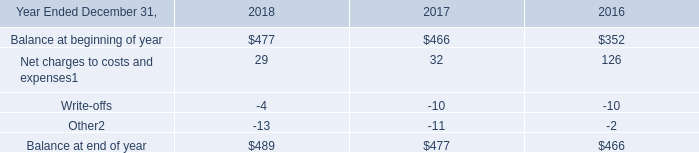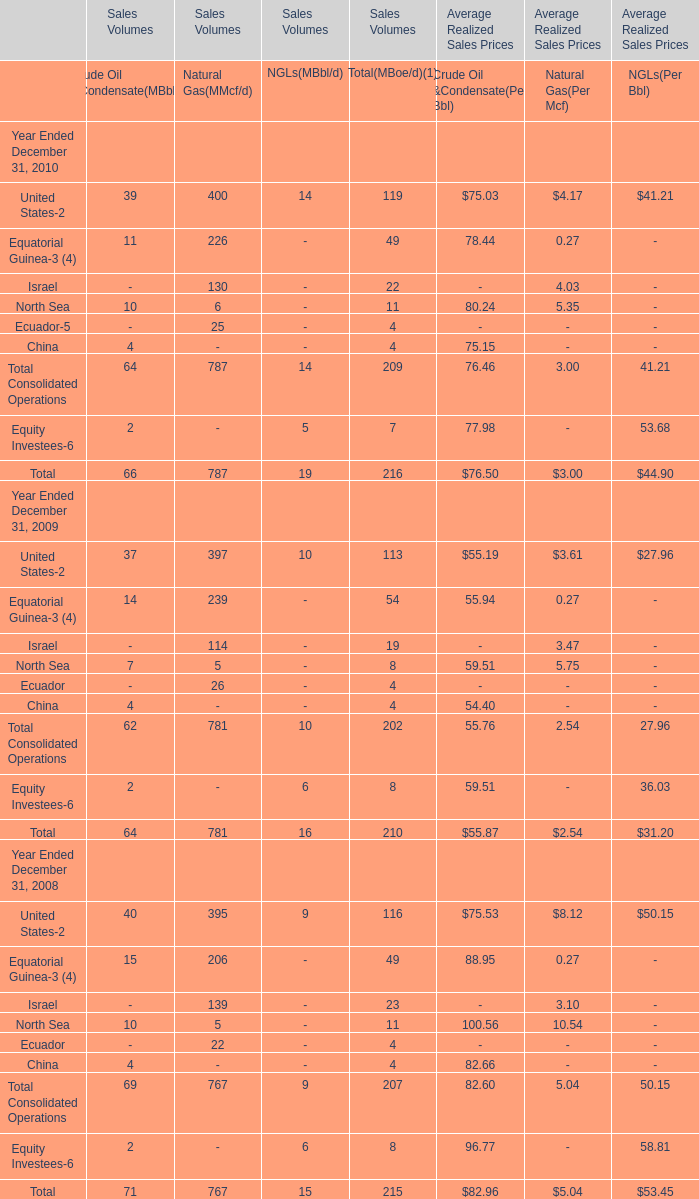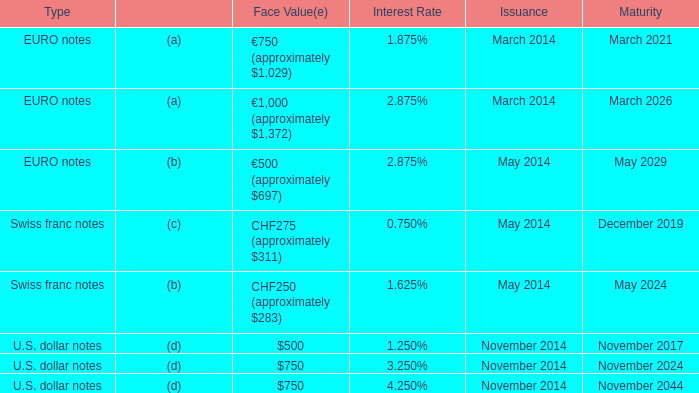What is the proportion of all NGLs(MBbl/d) that are greater than 0 to the total amount of NGLs(MBbl/d) in 2009? 
Computations: ((10 + 6) / 16)
Answer: 1.0. 